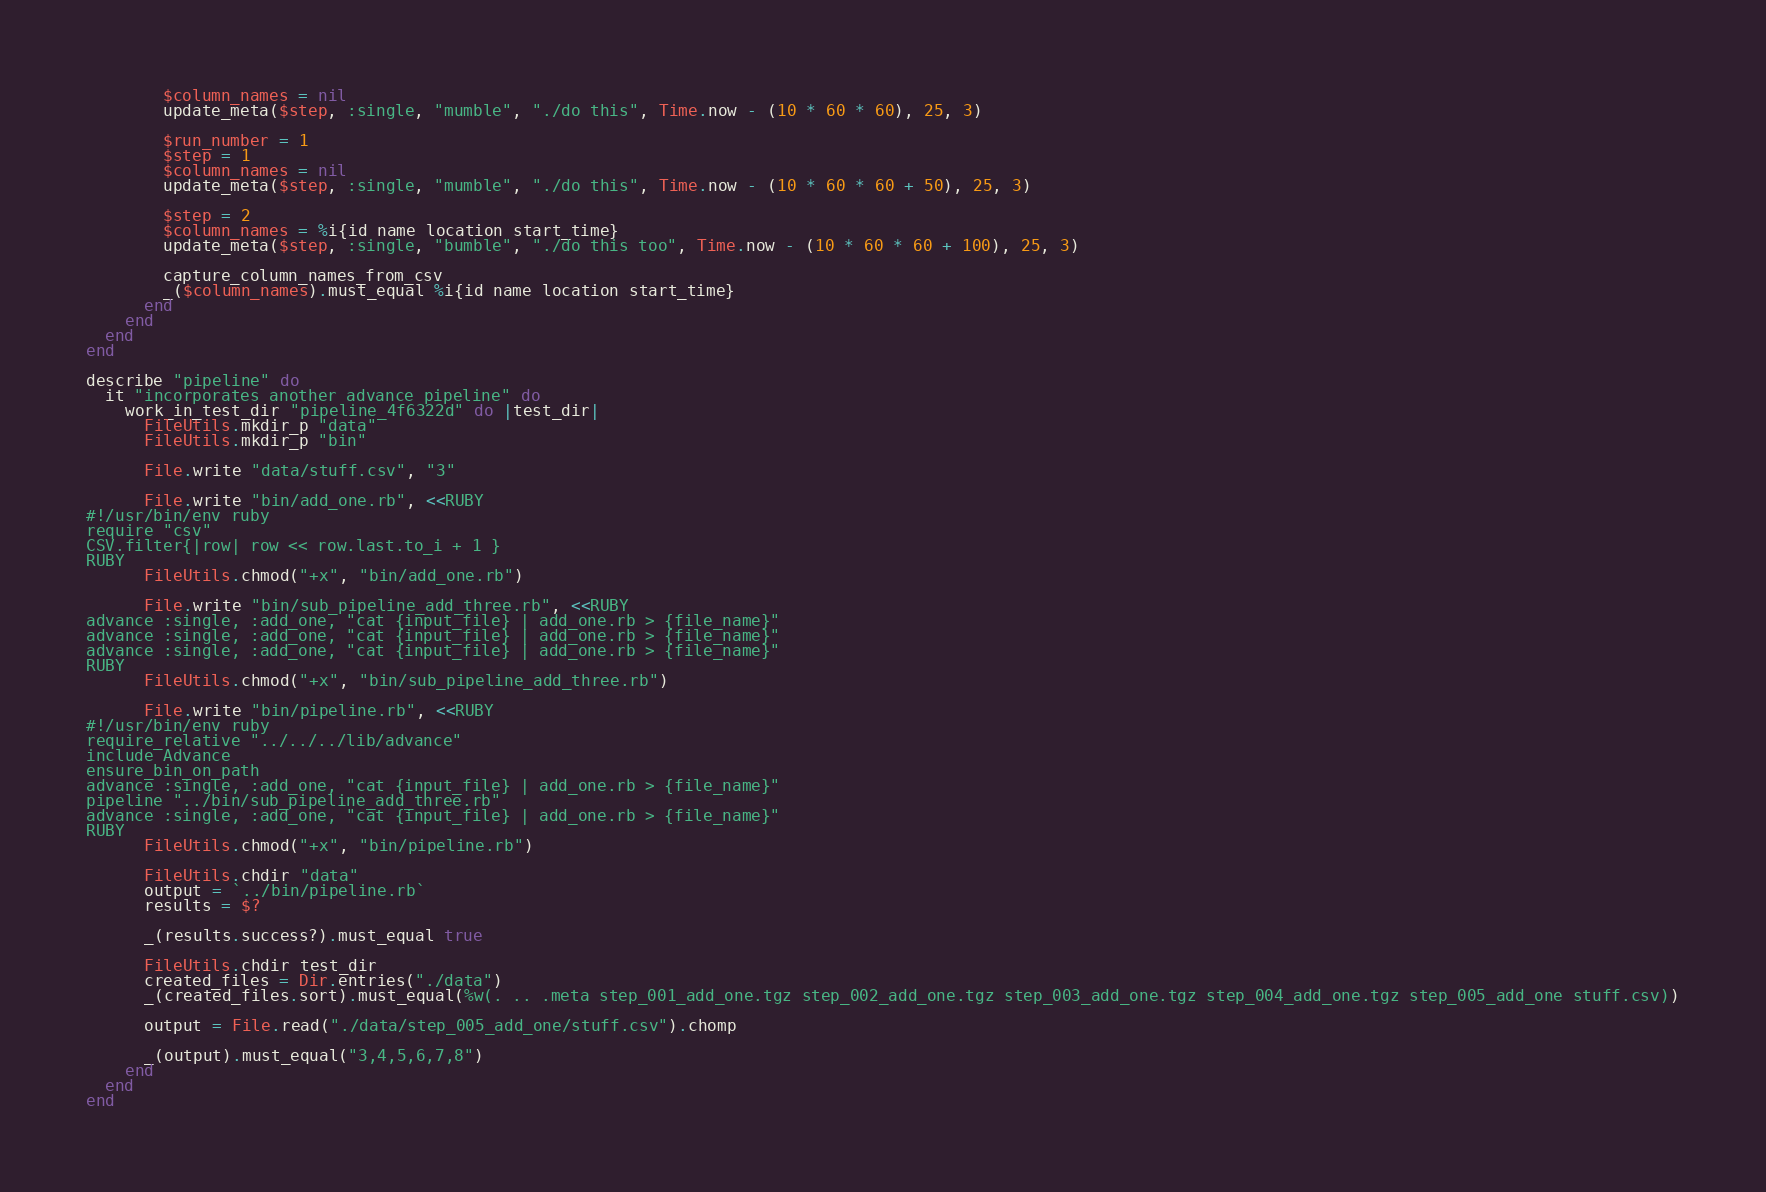Convert code to text. <code><loc_0><loc_0><loc_500><loc_500><_Ruby_>        $column_names = nil
        update_meta($step, :single, "mumble", "./do this", Time.now - (10 * 60 * 60), 25, 3)

        $run_number = 1
        $step = 1
        $column_names = nil
        update_meta($step, :single, "mumble", "./do this", Time.now - (10 * 60 * 60 + 50), 25, 3)

        $step = 2
        $column_names = %i{id name location start_time}
        update_meta($step, :single, "bumble", "./do this too", Time.now - (10 * 60 * 60 + 100), 25, 3)

        capture_column_names_from_csv
        _($column_names).must_equal %i{id name location start_time}
      end
    end
  end
end

describe "pipeline" do
  it "incorporates another advance pipeline" do
    work_in_test_dir "pipeline_4f6322d" do |test_dir|
      FileUtils.mkdir_p "data"
      FileUtils.mkdir_p "bin"

      File.write "data/stuff.csv", "3"

      File.write "bin/add_one.rb", <<RUBY
#!/usr/bin/env ruby
require "csv"
CSV.filter{|row| row << row.last.to_i + 1 }
RUBY
      FileUtils.chmod("+x", "bin/add_one.rb")

      File.write "bin/sub_pipeline_add_three.rb", <<RUBY
advance :single, :add_one, "cat {input_file} | add_one.rb > {file_name}"
advance :single, :add_one, "cat {input_file} | add_one.rb > {file_name}"
advance :single, :add_one, "cat {input_file} | add_one.rb > {file_name}"
RUBY
      FileUtils.chmod("+x", "bin/sub_pipeline_add_three.rb")

      File.write "bin/pipeline.rb", <<RUBY
#!/usr/bin/env ruby
require_relative "../../../lib/advance"
include Advance
ensure_bin_on_path
advance :single, :add_one, "cat {input_file} | add_one.rb > {file_name}"
pipeline "../bin/sub_pipeline_add_three.rb"
advance :single, :add_one, "cat {input_file} | add_one.rb > {file_name}"
RUBY
      FileUtils.chmod("+x", "bin/pipeline.rb")

      FileUtils.chdir "data"
      output = `../bin/pipeline.rb`
      results = $?

      _(results.success?).must_equal true

      FileUtils.chdir test_dir
      created_files = Dir.entries("./data")
      _(created_files.sort).must_equal(%w(. .. .meta step_001_add_one.tgz step_002_add_one.tgz step_003_add_one.tgz step_004_add_one.tgz step_005_add_one stuff.csv))

      output = File.read("./data/step_005_add_one/stuff.csv").chomp

      _(output).must_equal("3,4,5,6,7,8")
    end
  end
end
</code> 